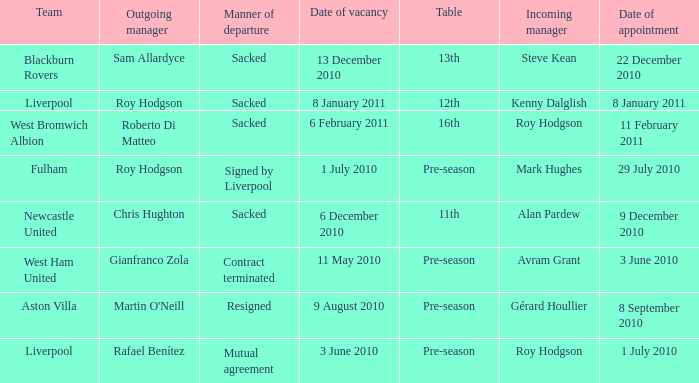What is the date of vacancy for the Liverpool team with a table named pre-season? 3 June 2010. Parse the table in full. {'header': ['Team', 'Outgoing manager', 'Manner of departure', 'Date of vacancy', 'Table', 'Incoming manager', 'Date of appointment'], 'rows': [['Blackburn Rovers', 'Sam Allardyce', 'Sacked', '13 December 2010', '13th', 'Steve Kean', '22 December 2010'], ['Liverpool', 'Roy Hodgson', 'Sacked', '8 January 2011', '12th', 'Kenny Dalglish', '8 January 2011'], ['West Bromwich Albion', 'Roberto Di Matteo', 'Sacked', '6 February 2011', '16th', 'Roy Hodgson', '11 February 2011'], ['Fulham', 'Roy Hodgson', 'Signed by Liverpool', '1 July 2010', 'Pre-season', 'Mark Hughes', '29 July 2010'], ['Newcastle United', 'Chris Hughton', 'Sacked', '6 December 2010', '11th', 'Alan Pardew', '9 December 2010'], ['West Ham United', 'Gianfranco Zola', 'Contract terminated', '11 May 2010', 'Pre-season', 'Avram Grant', '3 June 2010'], ['Aston Villa', "Martin O'Neill", 'Resigned', '9 August 2010', 'Pre-season', 'Gérard Houllier', '8 September 2010'], ['Liverpool', 'Rafael Benítez', 'Mutual agreement', '3 June 2010', 'Pre-season', 'Roy Hodgson', '1 July 2010']]} 